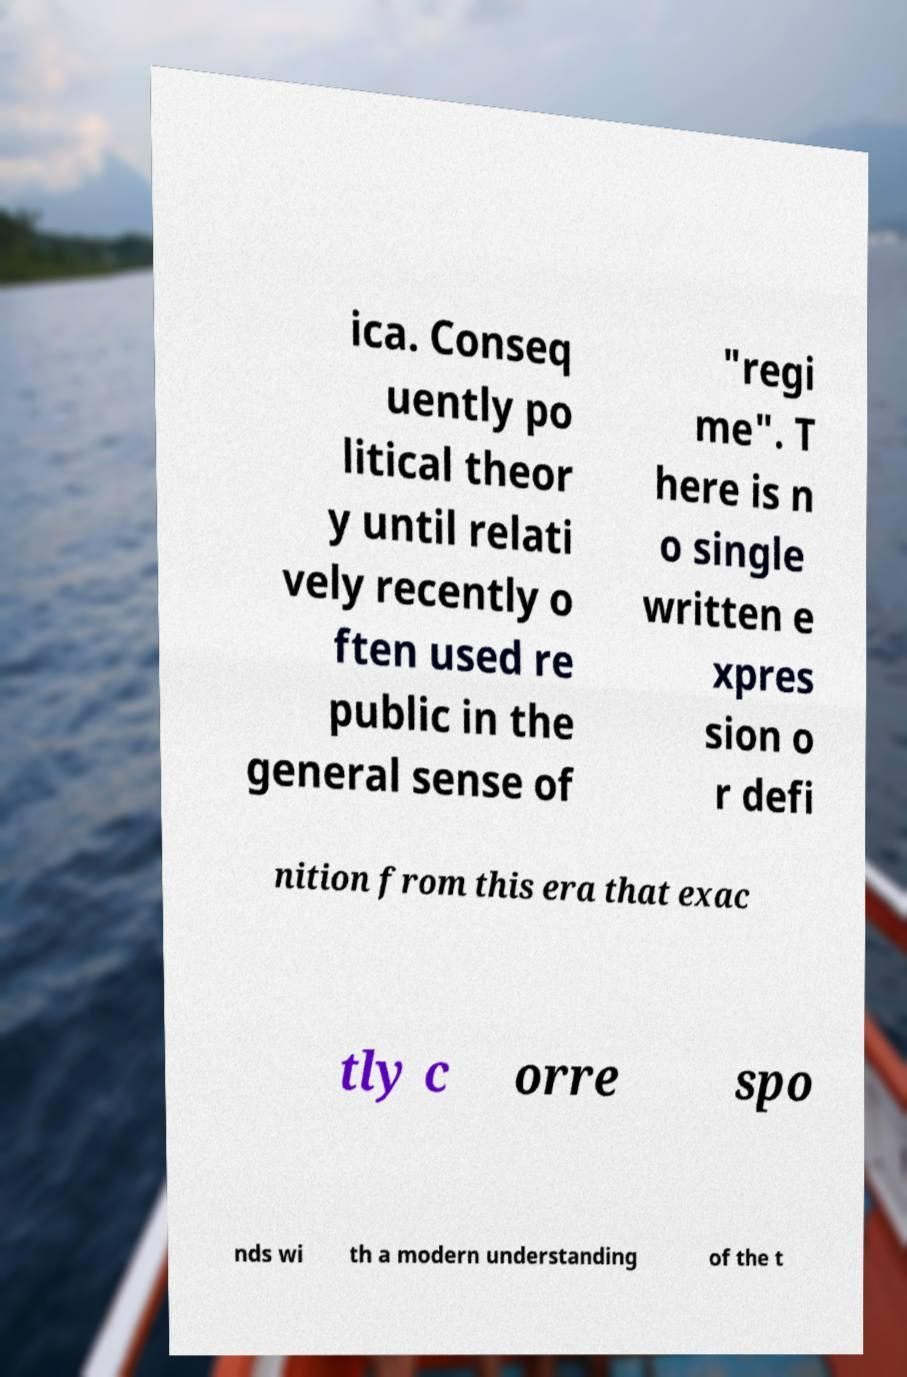Can you accurately transcribe the text from the provided image for me? ica. Conseq uently po litical theor y until relati vely recently o ften used re public in the general sense of "regi me". T here is n o single written e xpres sion o r defi nition from this era that exac tly c orre spo nds wi th a modern understanding of the t 